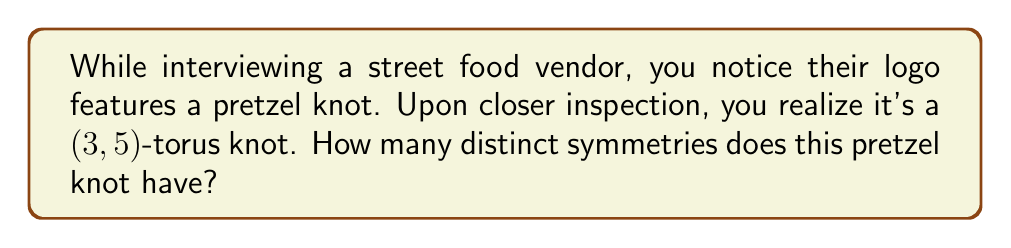Can you answer this question? To solve this problem, let's follow these steps:

1) First, recall that a $(p,q)$-torus knot is a knot that winds $p$ times around a torus in one direction and $q$ times in the other direction, where $p$ and $q$ are coprime integers.

2) In this case, we have a $(3,5)$-torus knot, which is also known as the cinquefoil knot.

3) The symmetry group of a $(p,q)$-torus knot is typically the dihedral group $D_n$, where $n = \min(p,q)$.

4) In our case, $\min(3,5) = 3$, so we're dealing with the dihedral group $D_3$.

5) The order of the dihedral group $D_n$ is given by the formula:

   $$|D_n| = 2n$$

6) Therefore, the order of $D_3$ is:

   $$|D_3| = 2 \cdot 3 = 6$$

7) This means that the $(3,5)$-torus knot has 6 distinct symmetries:
   - The identity symmetry
   - Three rotational symmetries (120°, 240°, 360°)
   - Two reflection symmetries

Thus, the pretzel knot in the vendor's logo has 6 distinct symmetries.
Answer: 6 